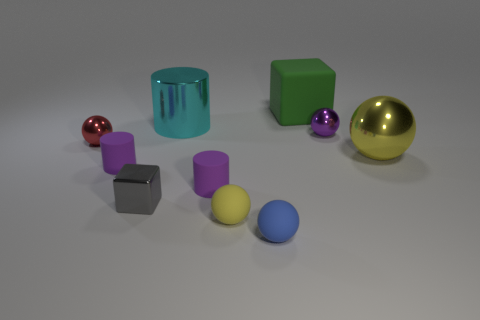What is the color of the shiny cylinder?
Your answer should be very brief. Cyan. Are there any yellow balls?
Provide a short and direct response. Yes. There is a small gray metal object; are there any big shiny spheres to the left of it?
Ensure brevity in your answer.  No. There is a large object that is the same shape as the small red shiny object; what is it made of?
Provide a succinct answer. Metal. Are there any other things that are made of the same material as the small blue ball?
Keep it short and to the point. Yes. What number of other objects are there of the same shape as the yellow matte object?
Give a very brief answer. 4. There is a large metallic object that is behind the shiny ball that is left of the small gray cube; what number of cyan shiny cylinders are behind it?
Your answer should be compact. 0. How many other objects have the same shape as the big cyan thing?
Offer a very short reply. 2. Does the metal thing on the right side of the purple metallic sphere have the same color as the large cube?
Your answer should be very brief. No. What shape is the small blue thing that is in front of the metal object that is behind the small purple object that is behind the red thing?
Keep it short and to the point. Sphere. 